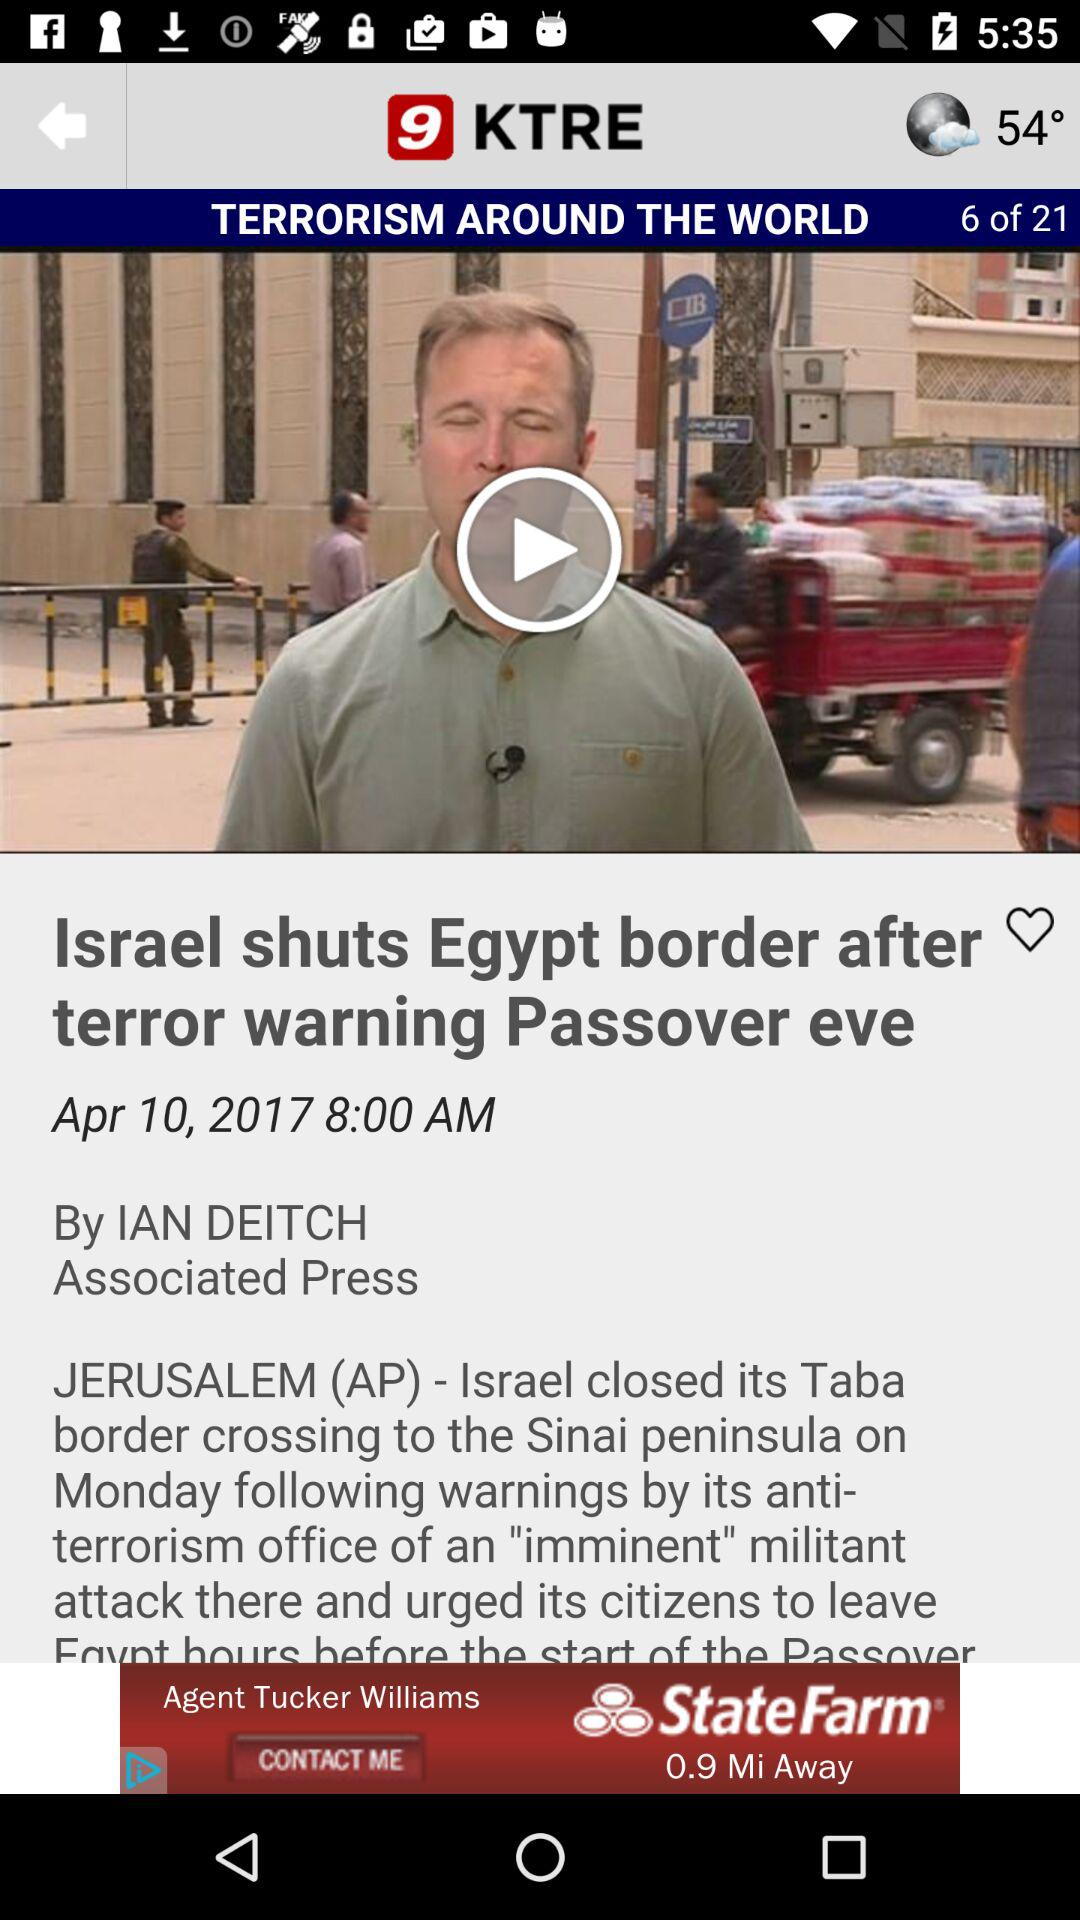At what time was the article posted? The article was posted at 8:00 AM. 